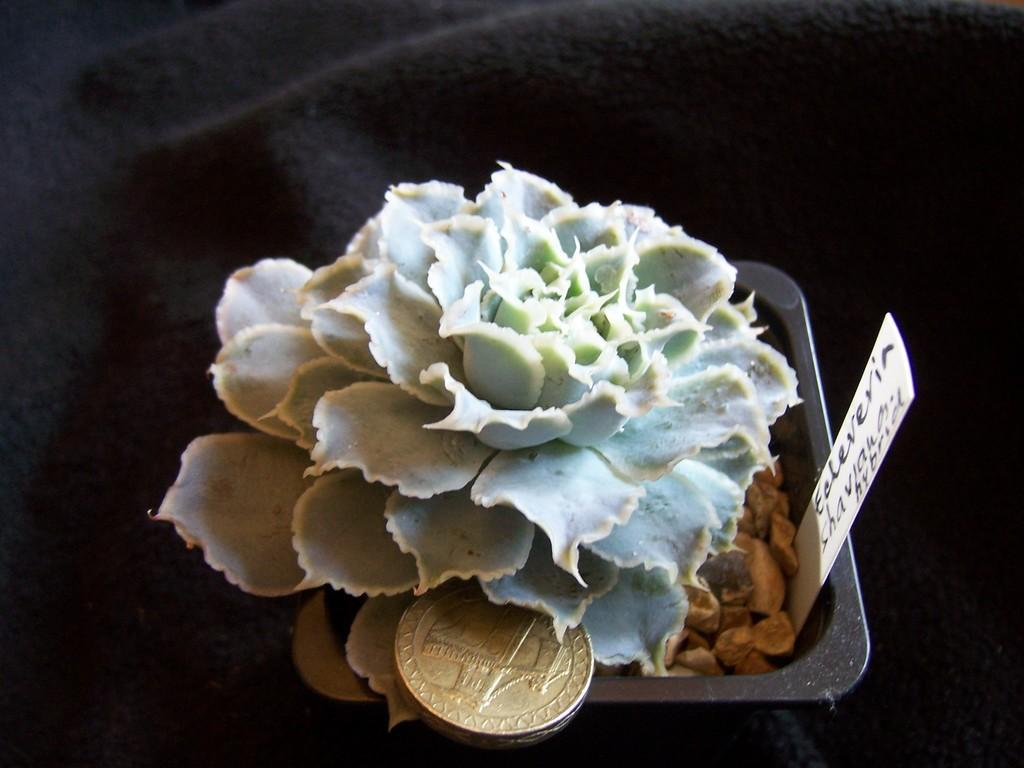What types of items can be seen in the image? There are food items, a coin, and a card in the image. Where are these items located? The food items, coin, and card are in a bowl. What is the bowl placed on? The bowl is on a cloth. What event is taking place in the image? There is no specific event depicted in the image; it simply shows a bowl containing food items, a coin, and a card on a cloth. How low is the respect shown in the image? The concept of respect is not applicable to the image, as it does not depict any social interactions or behaviors. 